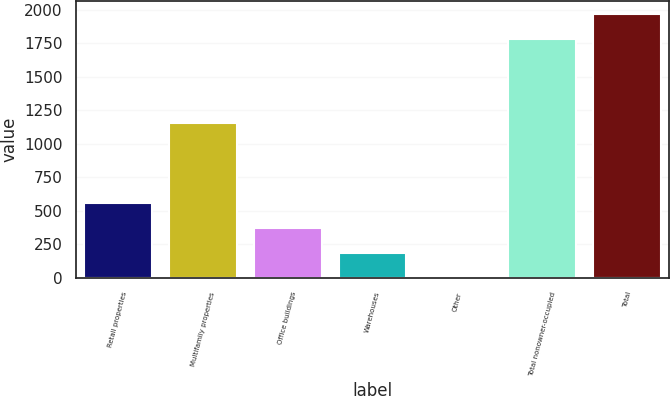Convert chart. <chart><loc_0><loc_0><loc_500><loc_500><bar_chart><fcel>Retail properties<fcel>Multifamily properties<fcel>Office buildings<fcel>Warehouses<fcel>Other<fcel>Total nonowner-occupied<fcel>Total<nl><fcel>554.8<fcel>1153<fcel>371.2<fcel>187.6<fcel>4<fcel>1782<fcel>1965.6<nl></chart> 